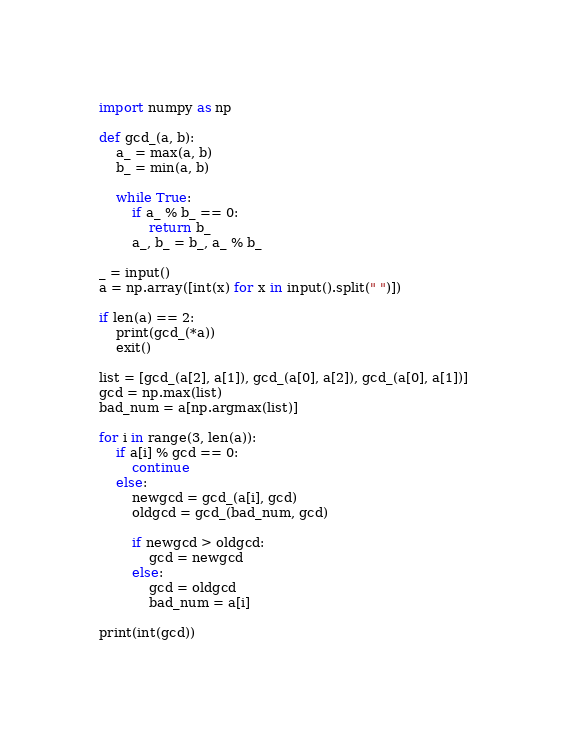Convert code to text. <code><loc_0><loc_0><loc_500><loc_500><_Python_>import numpy as np

def gcd_(a, b):
    a_ = max(a, b)
    b_ = min(a, b)

    while True:
        if a_ % b_ == 0:
            return b_
        a_, b_ = b_, a_ % b_

_ = input()
a = np.array([int(x) for x in input().split(" ")])

if len(a) == 2:
    print(gcd_(*a))
    exit()

list = [gcd_(a[2], a[1]), gcd_(a[0], a[2]), gcd_(a[0], a[1])]
gcd = np.max(list)
bad_num = a[np.argmax(list)]

for i in range(3, len(a)):
    if a[i] % gcd == 0:
        continue
    else:
        newgcd = gcd_(a[i], gcd)
        oldgcd = gcd_(bad_num, gcd)

        if newgcd > oldgcd:
            gcd = newgcd
        else:
            gcd = oldgcd
            bad_num = a[i]

print(int(gcd))</code> 